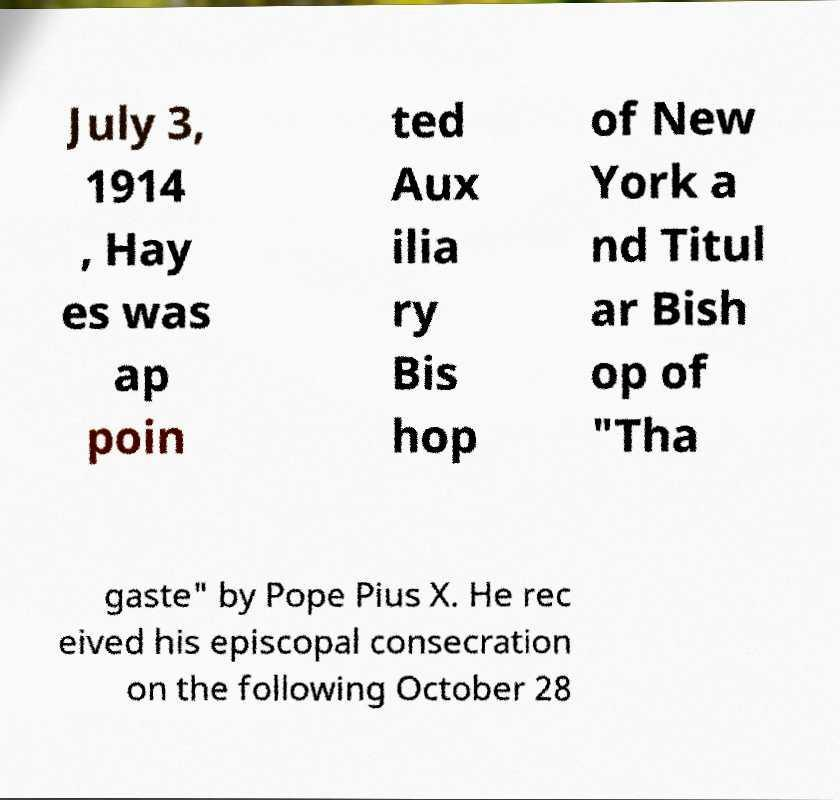Please identify and transcribe the text found in this image. July 3, 1914 , Hay es was ap poin ted Aux ilia ry Bis hop of New York a nd Titul ar Bish op of "Tha gaste" by Pope Pius X. He rec eived his episcopal consecration on the following October 28 